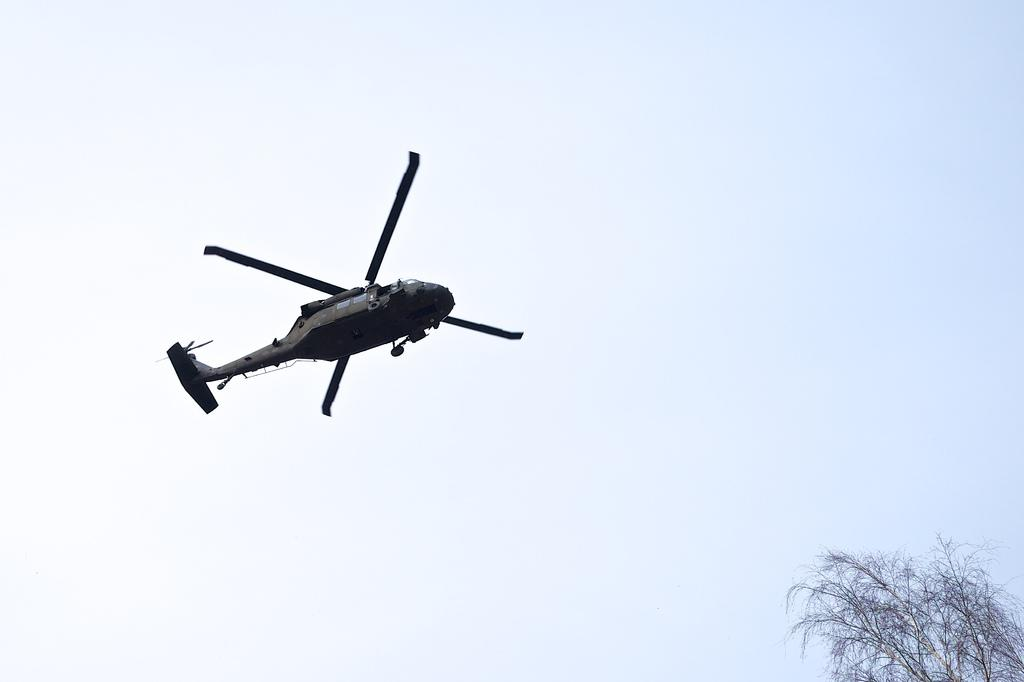What is flying in the sky in the image? There is a helicopter flying in the sky in the image. What can be seen in the right bottom corner of the image? There is a tree in the right bottom corner of the image. What is visible in the background of the image? The sky is visible in the background of the image. Can you tell me which actor is standing next to the helicopter in the image? There are no actors present in the image; it features a helicopter flying in the sky and a tree in the right bottom corner. What type of dust can be seen settling on the helicopter blades in the image? There is no dust visible on the helicopter blades in the image. 